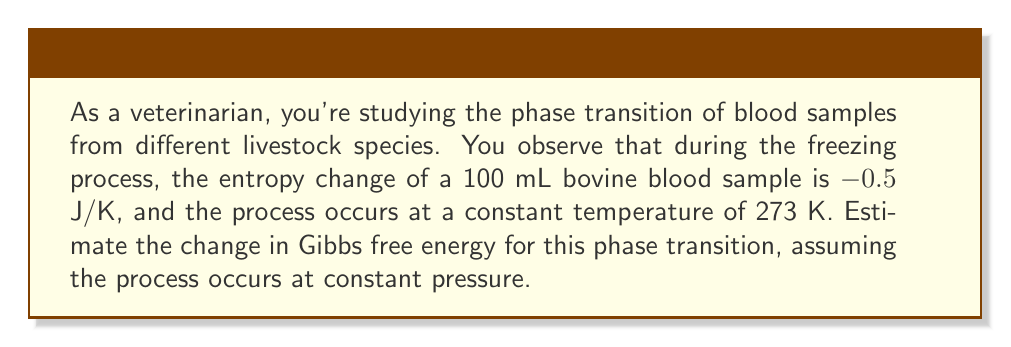Can you answer this question? To solve this problem, we'll use the fundamental equation for Gibbs free energy change:

$$\Delta G = \Delta H - T\Delta S$$

Where:
$\Delta G$ = Change in Gibbs free energy
$\Delta H$ = Change in enthalpy
$T$ = Temperature
$\Delta S$ = Change in entropy

For a phase transition at constant temperature and pressure:

1) The entropy change ($\Delta S$) is given: -0.5 J/K

2) The temperature ($T$) is given: 273 K

3) For a phase transition at constant pressure, the change in enthalpy ($\Delta H$) is equal to the latent heat of the transition. However, this value isn't provided, so we'll assume it's negligible compared to the $T\Delta S$ term.

4) Substituting these values into the equation:

   $$\Delta G = 0 - (273 \text{ K})(-0.5 \text{ J/K})$$

5) Simplifying:

   $$\Delta G = 273 \text{ K} \times 0.5 \text{ J/K} = 136.5 \text{ J}$$

Thus, the estimated change in Gibbs free energy for this phase transition is 136.5 J.
Answer: 136.5 J 